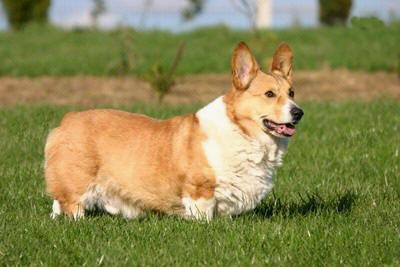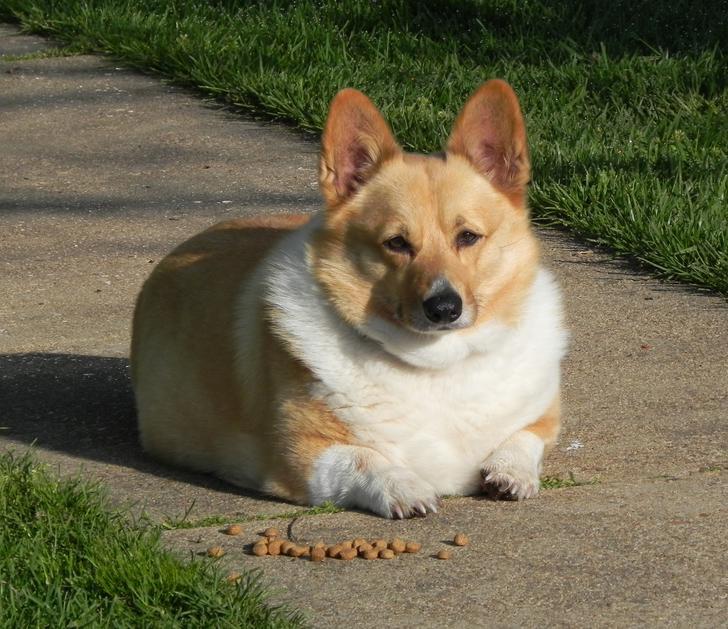The first image is the image on the left, the second image is the image on the right. For the images displayed, is the sentence "A dog is facing to the left with his head raised up in a picture." factually correct? Answer yes or no. No. The first image is the image on the left, the second image is the image on the right. Evaluate the accuracy of this statement regarding the images: "All short-legged dogs are standing alert on some grass.". Is it true? Answer yes or no. No. 